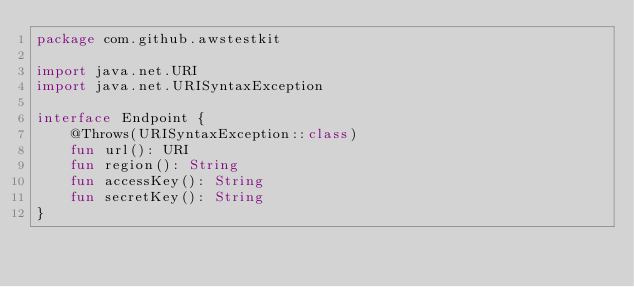<code> <loc_0><loc_0><loc_500><loc_500><_Kotlin_>package com.github.awstestkit

import java.net.URI
import java.net.URISyntaxException

interface Endpoint {
    @Throws(URISyntaxException::class)
    fun url(): URI
    fun region(): String
    fun accessKey(): String
    fun secretKey(): String
}
</code> 